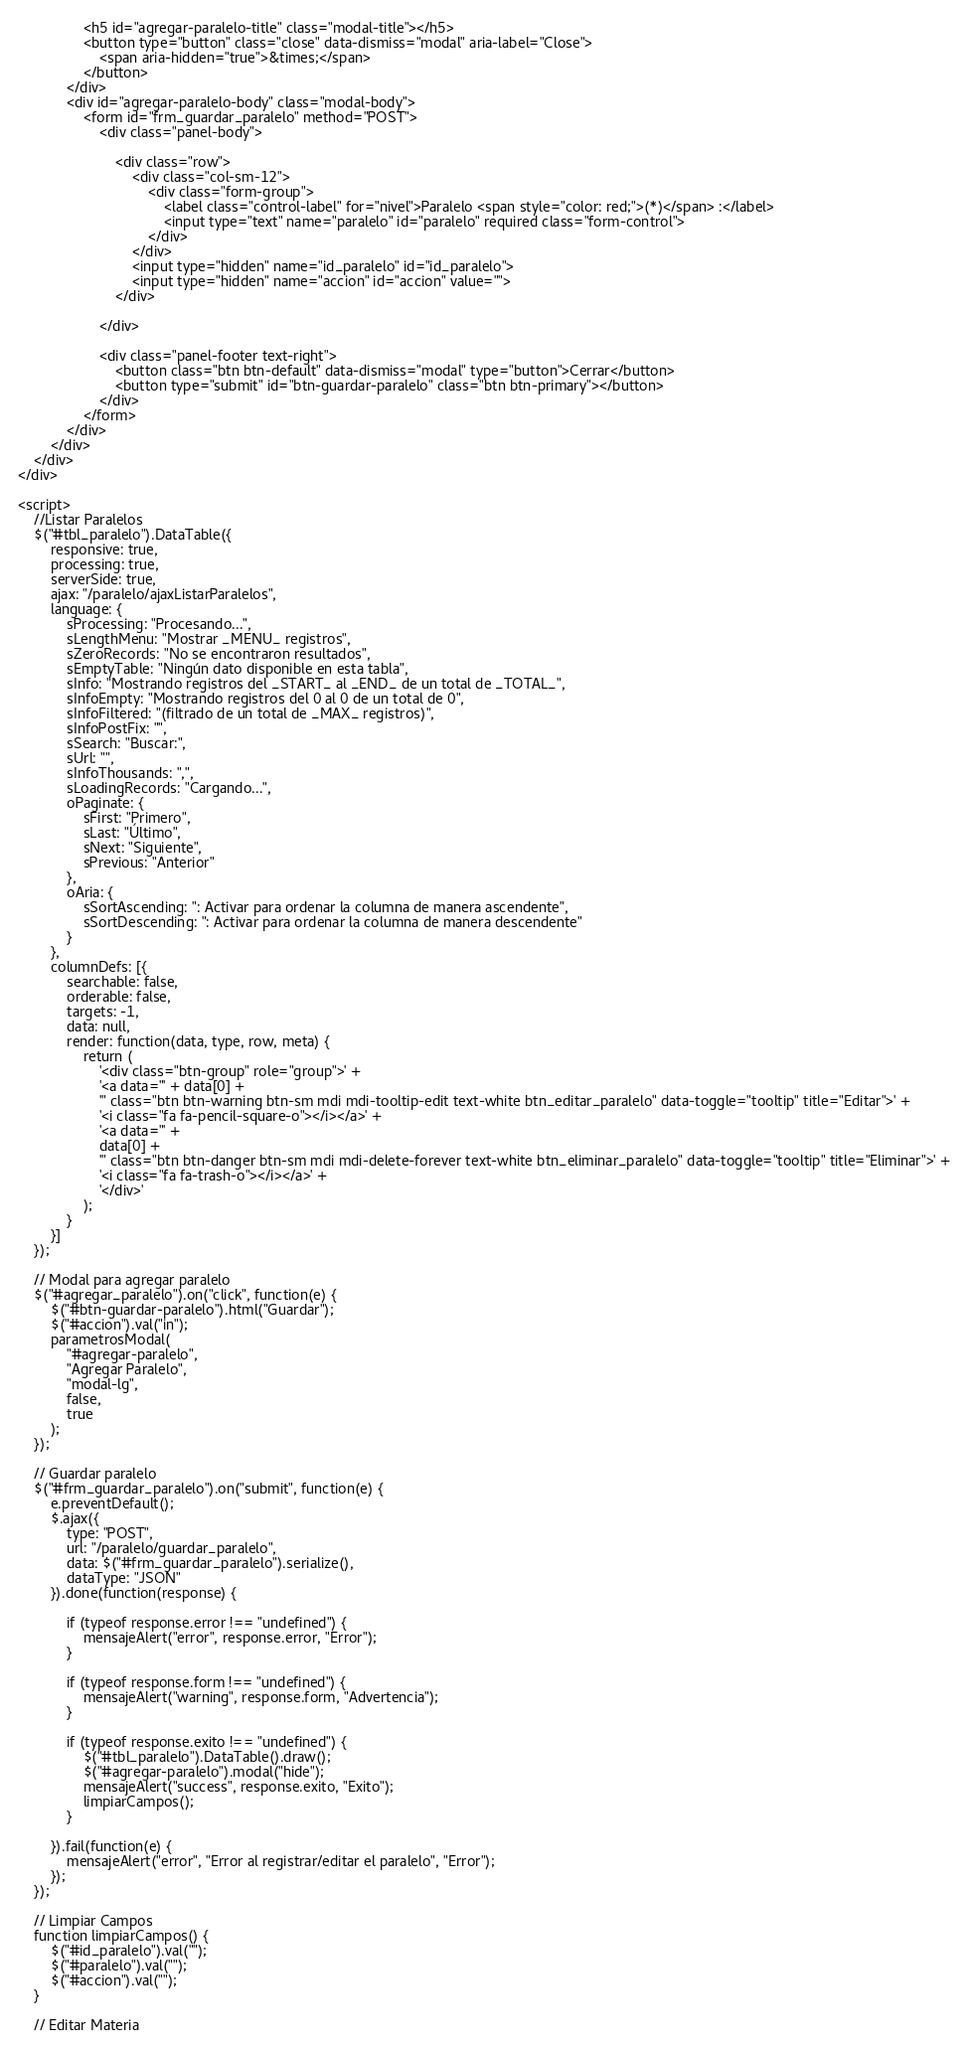Convert code to text. <code><loc_0><loc_0><loc_500><loc_500><_PHP_>                <h5 id="agregar-paralelo-title" class="modal-title"></h5>
                <button type="button" class="close" data-dismiss="modal" aria-label="Close">
                    <span aria-hidden="true">&times;</span>
                </button>
            </div>
            <div id="agregar-paralelo-body" class="modal-body">
                <form id="frm_guardar_paralelo" method="POST">
                    <div class="panel-body">

                        <div class="row">
                            <div class="col-sm-12">
                                <div class="form-group">
                                    <label class="control-label" for="nivel">Paralelo <span style="color: red;">(*)</span> :</label>
                                    <input type="text" name="paralelo" id="paralelo" required class="form-control">
                                </div>
                            </div>
                            <input type="hidden" name="id_paralelo" id="id_paralelo">
                            <input type="hidden" name="accion" id="accion" value="">
                        </div>

                    </div>

                    <div class="panel-footer text-right">
                        <button class="btn btn-default" data-dismiss="modal" type="button">Cerrar</button>
                        <button type="submit" id="btn-guardar-paralelo" class="btn btn-primary"></button>
                    </div>
                </form>
            </div>
        </div>
    </div>
</div>

<script>
    //Listar Paralelos
    $("#tbl_paralelo").DataTable({
        responsive: true,
        processing: true,
        serverSide: true,
        ajax: "/paralelo/ajaxListarParalelos",
        language: {
            sProcessing: "Procesando...",
            sLengthMenu: "Mostrar _MENU_ registros",
            sZeroRecords: "No se encontraron resultados",
            sEmptyTable: "Ningún dato disponible en esta tabla",
            sInfo: "Mostrando registros del _START_ al _END_ de un total de _TOTAL_",
            sInfoEmpty: "Mostrando registros del 0 al 0 de un total de 0",
            sInfoFiltered: "(filtrado de un total de _MAX_ registros)",
            sInfoPostFix: "",
            sSearch: "Buscar:",
            sUrl: "",
            sInfoThousands: ",",
            sLoadingRecords: "Cargando...",
            oPaginate: {
                sFirst: "Primero",
                sLast: "Último",
                sNext: "Siguiente",
                sPrevious: "Anterior"
            },
            oAria: {
                sSortAscending: ": Activar para ordenar la columna de manera ascendente",
                sSortDescending: ": Activar para ordenar la columna de manera descendente"
            }
        },
        columnDefs: [{
            searchable: false,
            orderable: false,
            targets: -1,
            data: null,
            render: function(data, type, row, meta) {
                return (
                    '<div class="btn-group" role="group">' +
                    '<a data="' + data[0] +
                    '" class="btn btn-warning btn-sm mdi mdi-tooltip-edit text-white btn_editar_paralelo" data-toggle="tooltip" title="Editar">' +
                    '<i class="fa fa-pencil-square-o"></i></a>' +
                    '<a data="' +
                    data[0] +
                    '" class="btn btn-danger btn-sm mdi mdi-delete-forever text-white btn_eliminar_paralelo" data-toggle="tooltip" title="Eliminar">' +
                    '<i class="fa fa-trash-o"></i></a>' +
                    '</div>'
                );
            }
        }]
    });

    // Modal para agregar paralelo
    $("#agregar_paralelo").on("click", function(e) {
        $("#btn-guardar-paralelo").html("Guardar");
        $("#accion").val("in");
        parametrosModal(
            "#agregar-paralelo",
            "Agregar Paralelo",
            "modal-lg",
            false,
            true
        );
    });

    // Guardar paralelo
    $("#frm_guardar_paralelo").on("submit", function(e) {
        e.preventDefault();
        $.ajax({
            type: "POST",
            url: "/paralelo/guardar_paralelo",
            data: $("#frm_guardar_paralelo").serialize(),
            dataType: "JSON"
        }).done(function(response) {

            if (typeof response.error !== "undefined") {
                mensajeAlert("error", response.error, "Error");
            }

            if (typeof response.form !== "undefined") {
                mensajeAlert("warning", response.form, "Advertencia");
            }

            if (typeof response.exito !== "undefined") {
                $("#tbl_paralelo").DataTable().draw();
                $("#agregar-paralelo").modal("hide");
                mensajeAlert("success", response.exito, "Exito");
                limpiarCampos();
            }

        }).fail(function(e) {
            mensajeAlert("error", "Error al registrar/editar el paralelo", "Error");
        });
    });

    // Limpiar Campos
    function limpiarCampos() {
        $("#id_paralelo").val("");
        $("#paralelo").val("");
        $("#accion").val("");
    }

    // Editar Materia</code> 